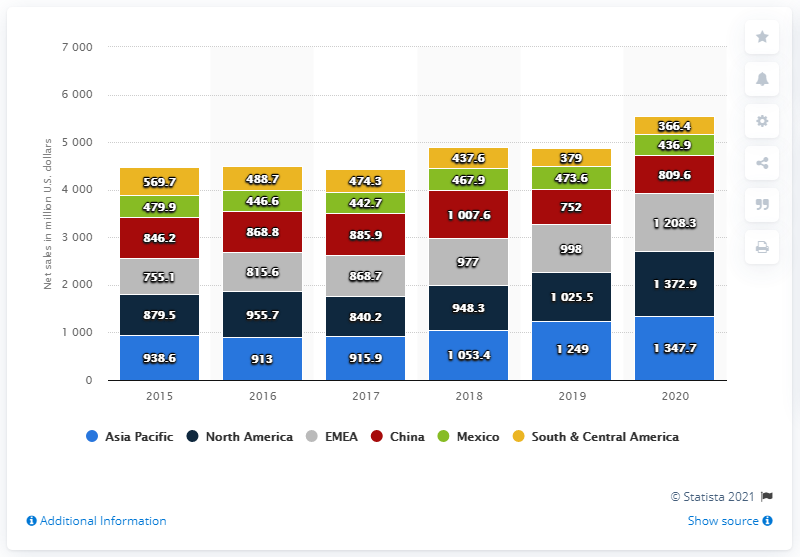Point out several critical features in this image. In 2020, Herbalife's global net sales in the Asia Pacific region amounted to 1347.7... 